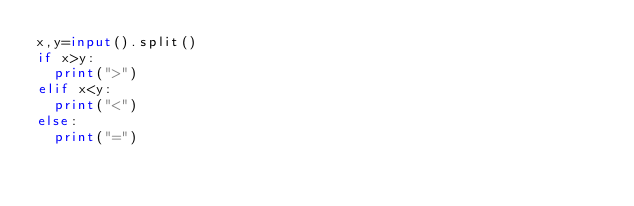Convert code to text. <code><loc_0><loc_0><loc_500><loc_500><_Python_>x,y=input().split()
if x>y:
  print(">")
elif x<y:
  print("<")
else:
  print("=")</code> 